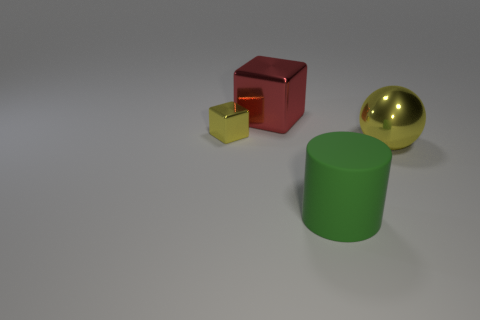Are there the same number of large green cylinders in front of the metallic sphere and large red cubes?
Provide a succinct answer. Yes. Are there any other things that have the same material as the big green object?
Provide a short and direct response. No. There is a metallic ball; is it the same color as the tiny metal object that is on the left side of the matte object?
Offer a very short reply. Yes. There is a big shiny block that is to the left of the thing that is to the right of the large green thing; are there any small yellow shiny objects that are to the left of it?
Your answer should be compact. Yes. Are there fewer big red metallic cubes that are in front of the small metal object than cyan objects?
Your answer should be very brief. No. How many other things are there of the same shape as the matte thing?
Give a very brief answer. 0. What number of things are either big shiny objects on the left side of the large sphere or metal cubes right of the small yellow cube?
Make the answer very short. 1. What is the size of the thing that is in front of the red thing and to the left of the big rubber thing?
Your answer should be very brief. Small. There is a large metallic object that is behind the big yellow object; is its shape the same as the big green object?
Make the answer very short. No. What size is the yellow object that is in front of the yellow shiny thing that is behind the metal thing that is right of the big red metal object?
Keep it short and to the point. Large. 